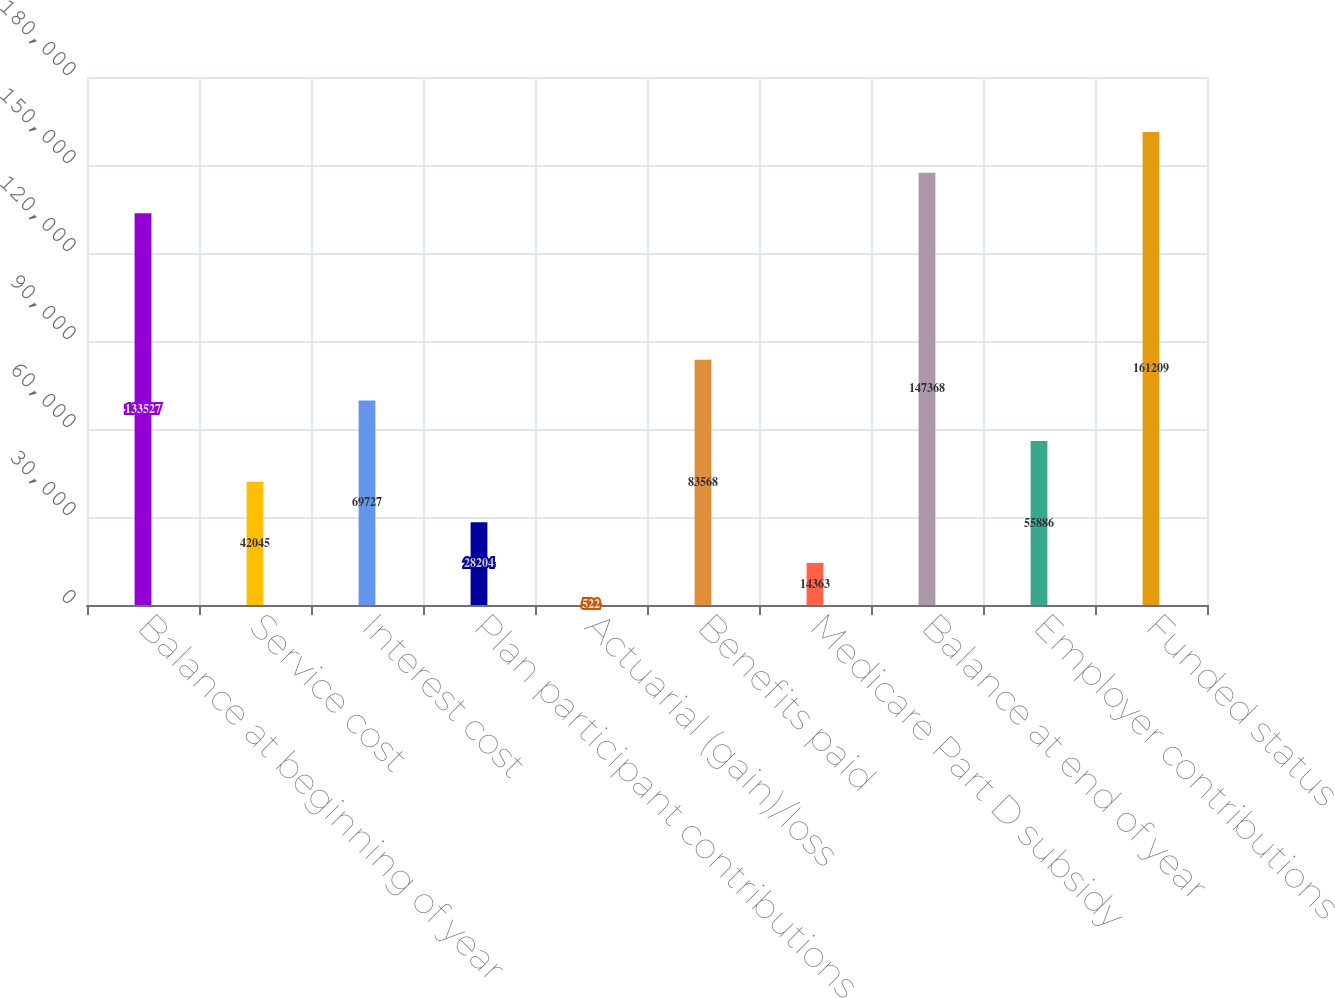Convert chart. <chart><loc_0><loc_0><loc_500><loc_500><bar_chart><fcel>Balance at beginning of year<fcel>Service cost<fcel>Interest cost<fcel>Plan participant contributions<fcel>Actuarial (gain)/loss<fcel>Benefits paid<fcel>Medicare Part D subsidy<fcel>Balance at end of year<fcel>Employer contributions<fcel>Funded status<nl><fcel>133527<fcel>42045<fcel>69727<fcel>28204<fcel>522<fcel>83568<fcel>14363<fcel>147368<fcel>55886<fcel>161209<nl></chart> 